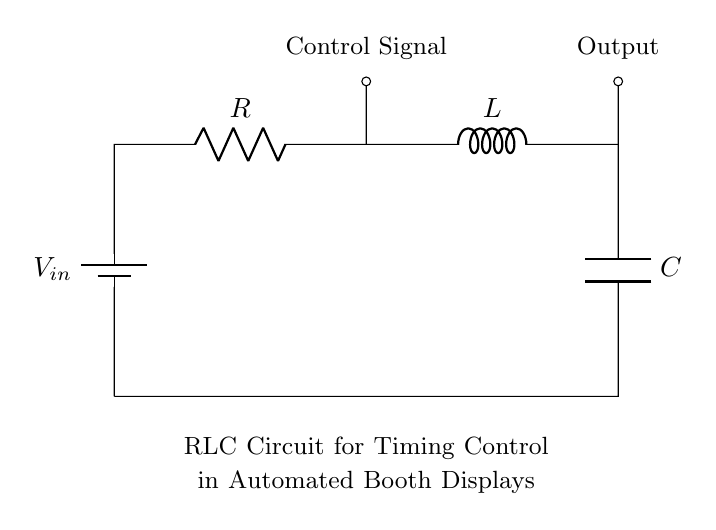What are the components of this circuit? The components in the circuit are a battery, resistor, inductor, and capacitor. They are arranged in series, which is a common setup for RLC circuits.
Answer: battery, resistor, inductor, capacitor What is the function of the control signal in this circuit? The control signal is used to operate or manage the timing of the automated booth display. It indicates when the circuit should change its state or react to inputs, affecting the output behavior.
Answer: operation What is the type of circuit depicted? The circuit is an RLC circuit, which combines a resistor, inductor, and capacitor for timing control applications. This type of circuit is often utilized in oscillators, filters, and timers.
Answer: RLC circuit What is the orientation of the battery in the circuit? The battery is oriented vertically in the diagram, with the positive terminal at the top, indicating the direction of current flow. The positive side pushes current through the circuit.
Answer: vertical How does the inductor influence the timing behavior of the circuit? The inductor stores energy in a magnetic field when current flows through it. This leads to a delay in the current change, which is key for timing control as it creates a phase difference between current and voltage, affecting the overall timing response.
Answer: delays current change What happens to the output when the capacitor charges fully? When the capacitor is fully charged, it ceases to allow current flow, effectively stopping the output signal until the circuit resets or discharges the capacitor. This behavior is crucial for timing applications where intervals of no signal are needed.
Answer: output stops 